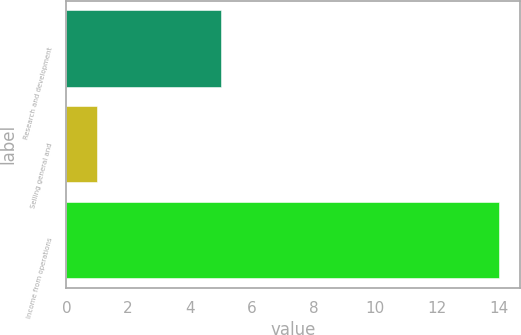<chart> <loc_0><loc_0><loc_500><loc_500><bar_chart><fcel>Research and development<fcel>Selling general and<fcel>Income from operations<nl><fcel>5<fcel>1<fcel>14<nl></chart> 